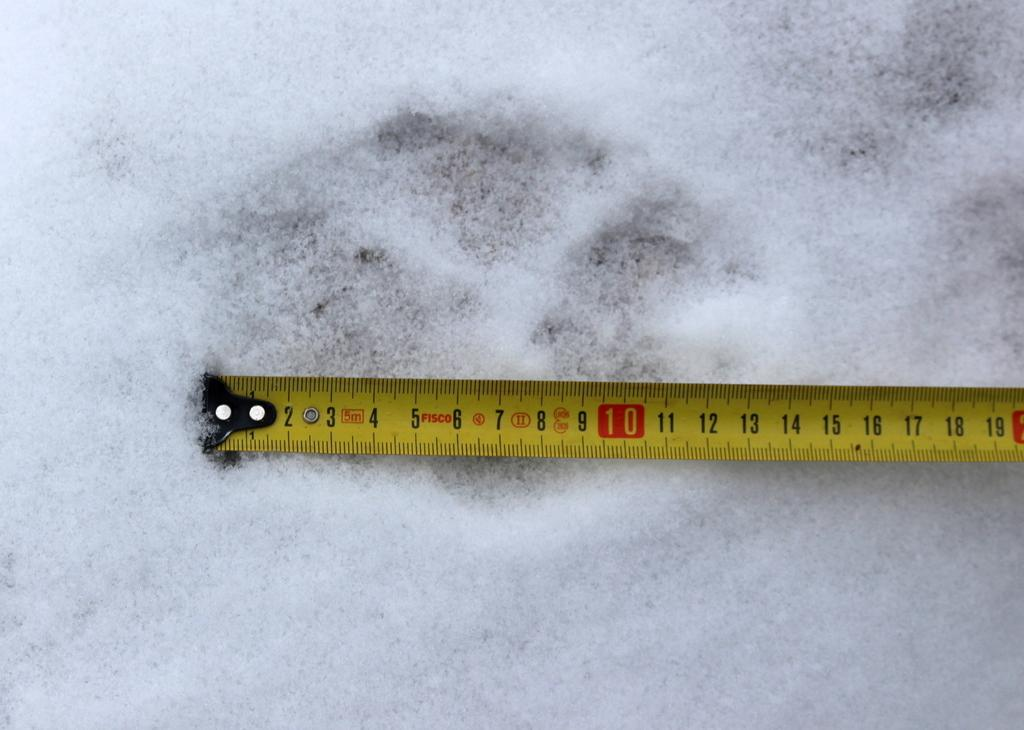Provide a one-sentence caption for the provided image. A Fisco brand tape measure is on a white surface. 